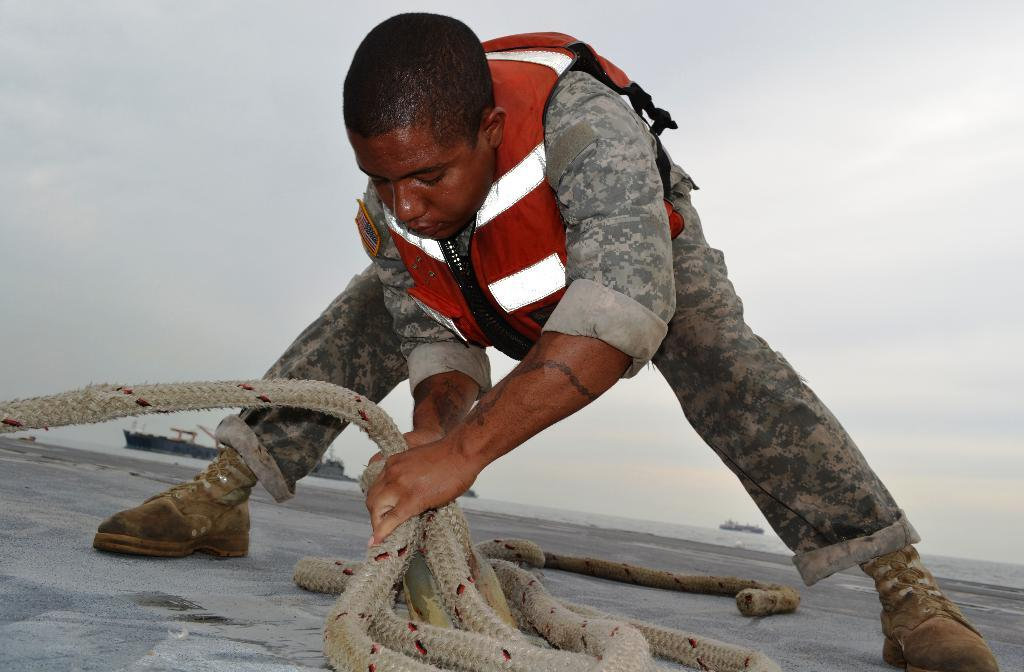What is the main subject of the image? There is a person standing in the middle of the image. What is the person holding in the image? The person is holding a rope. What can be seen in the sky in the background of the image? There are clouds visible in the sky in the background of the image. How many legs does the sheep have in the image? There is no sheep present in the image. What type of flesh can be seen on the person's hands in the image? There is no flesh visible on the person's hands in the image; the person is holding a rope. 